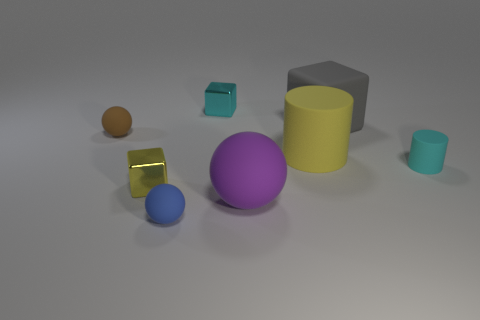There is a large cylinder; does it have the same color as the small cube that is on the left side of the blue matte thing? Yes, the large cylinder and the small cube to the left of the blue object both share a similar shade of yellow, although lighting conditions could affect color perception slightly. 